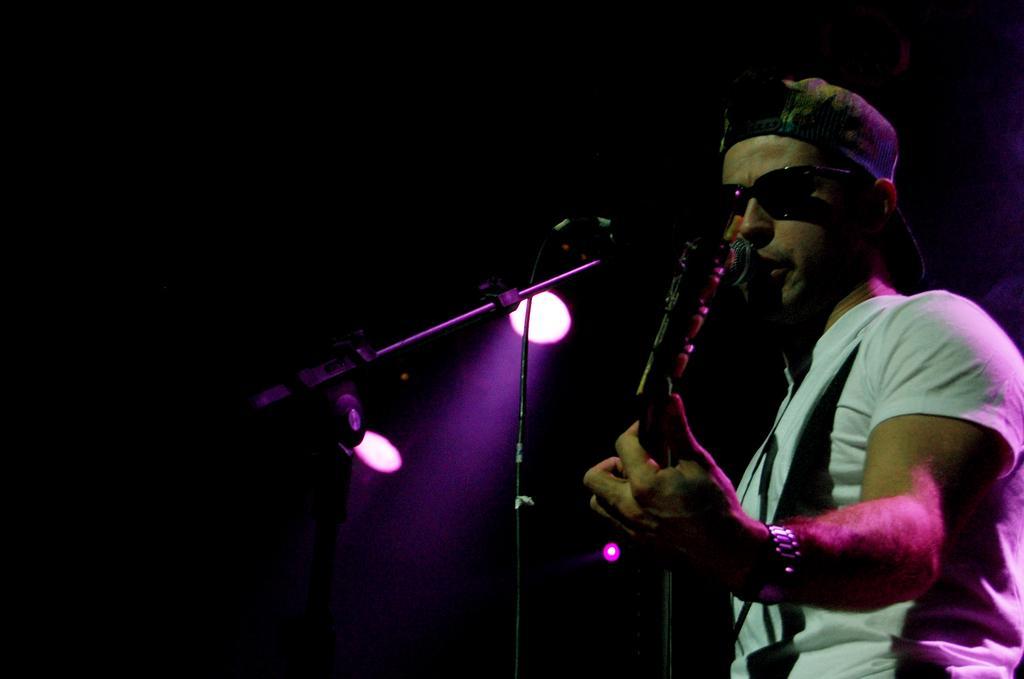Please provide a concise description of this image. On the right side of this image there is a man wearing a t-shirt, cap on the head and playing the guitar. This person is facing towards the left side. In front of this man there is a mike stand. In the background there are two lights in the dark. 